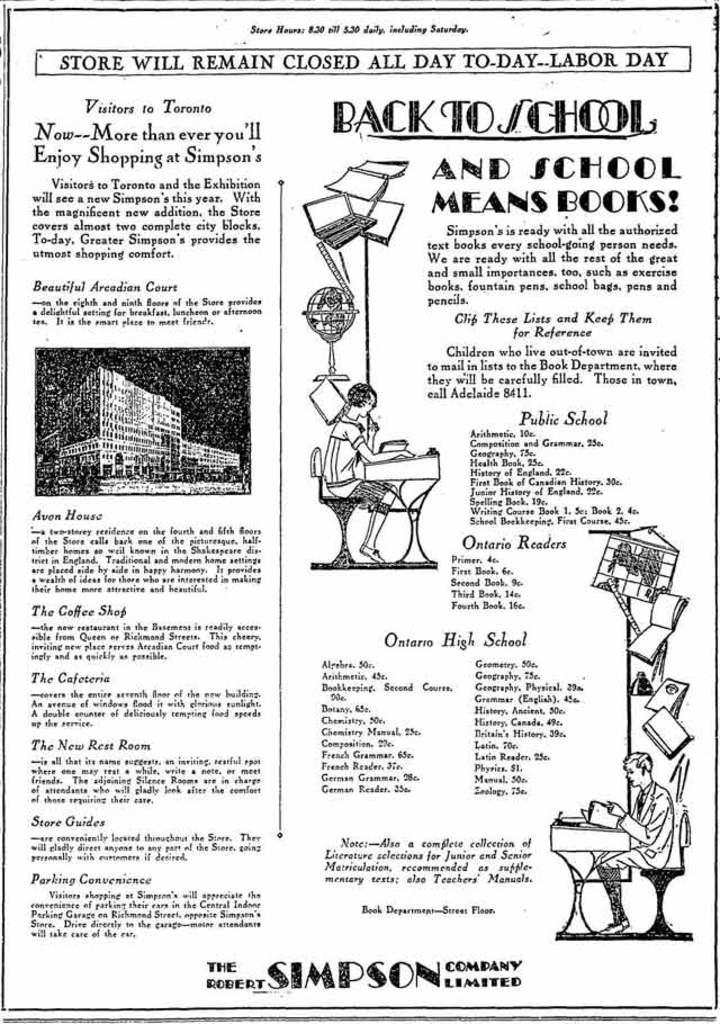Can you describe this image briefly? In this image there is a paper and we can see text. There are images of building, persons, table, books and some things on the paper. 